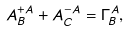Convert formula to latex. <formula><loc_0><loc_0><loc_500><loc_500>A ^ { + A } _ { B } + A ^ { - A } _ { C } = \Gamma ^ { A } _ { B } ,</formula> 